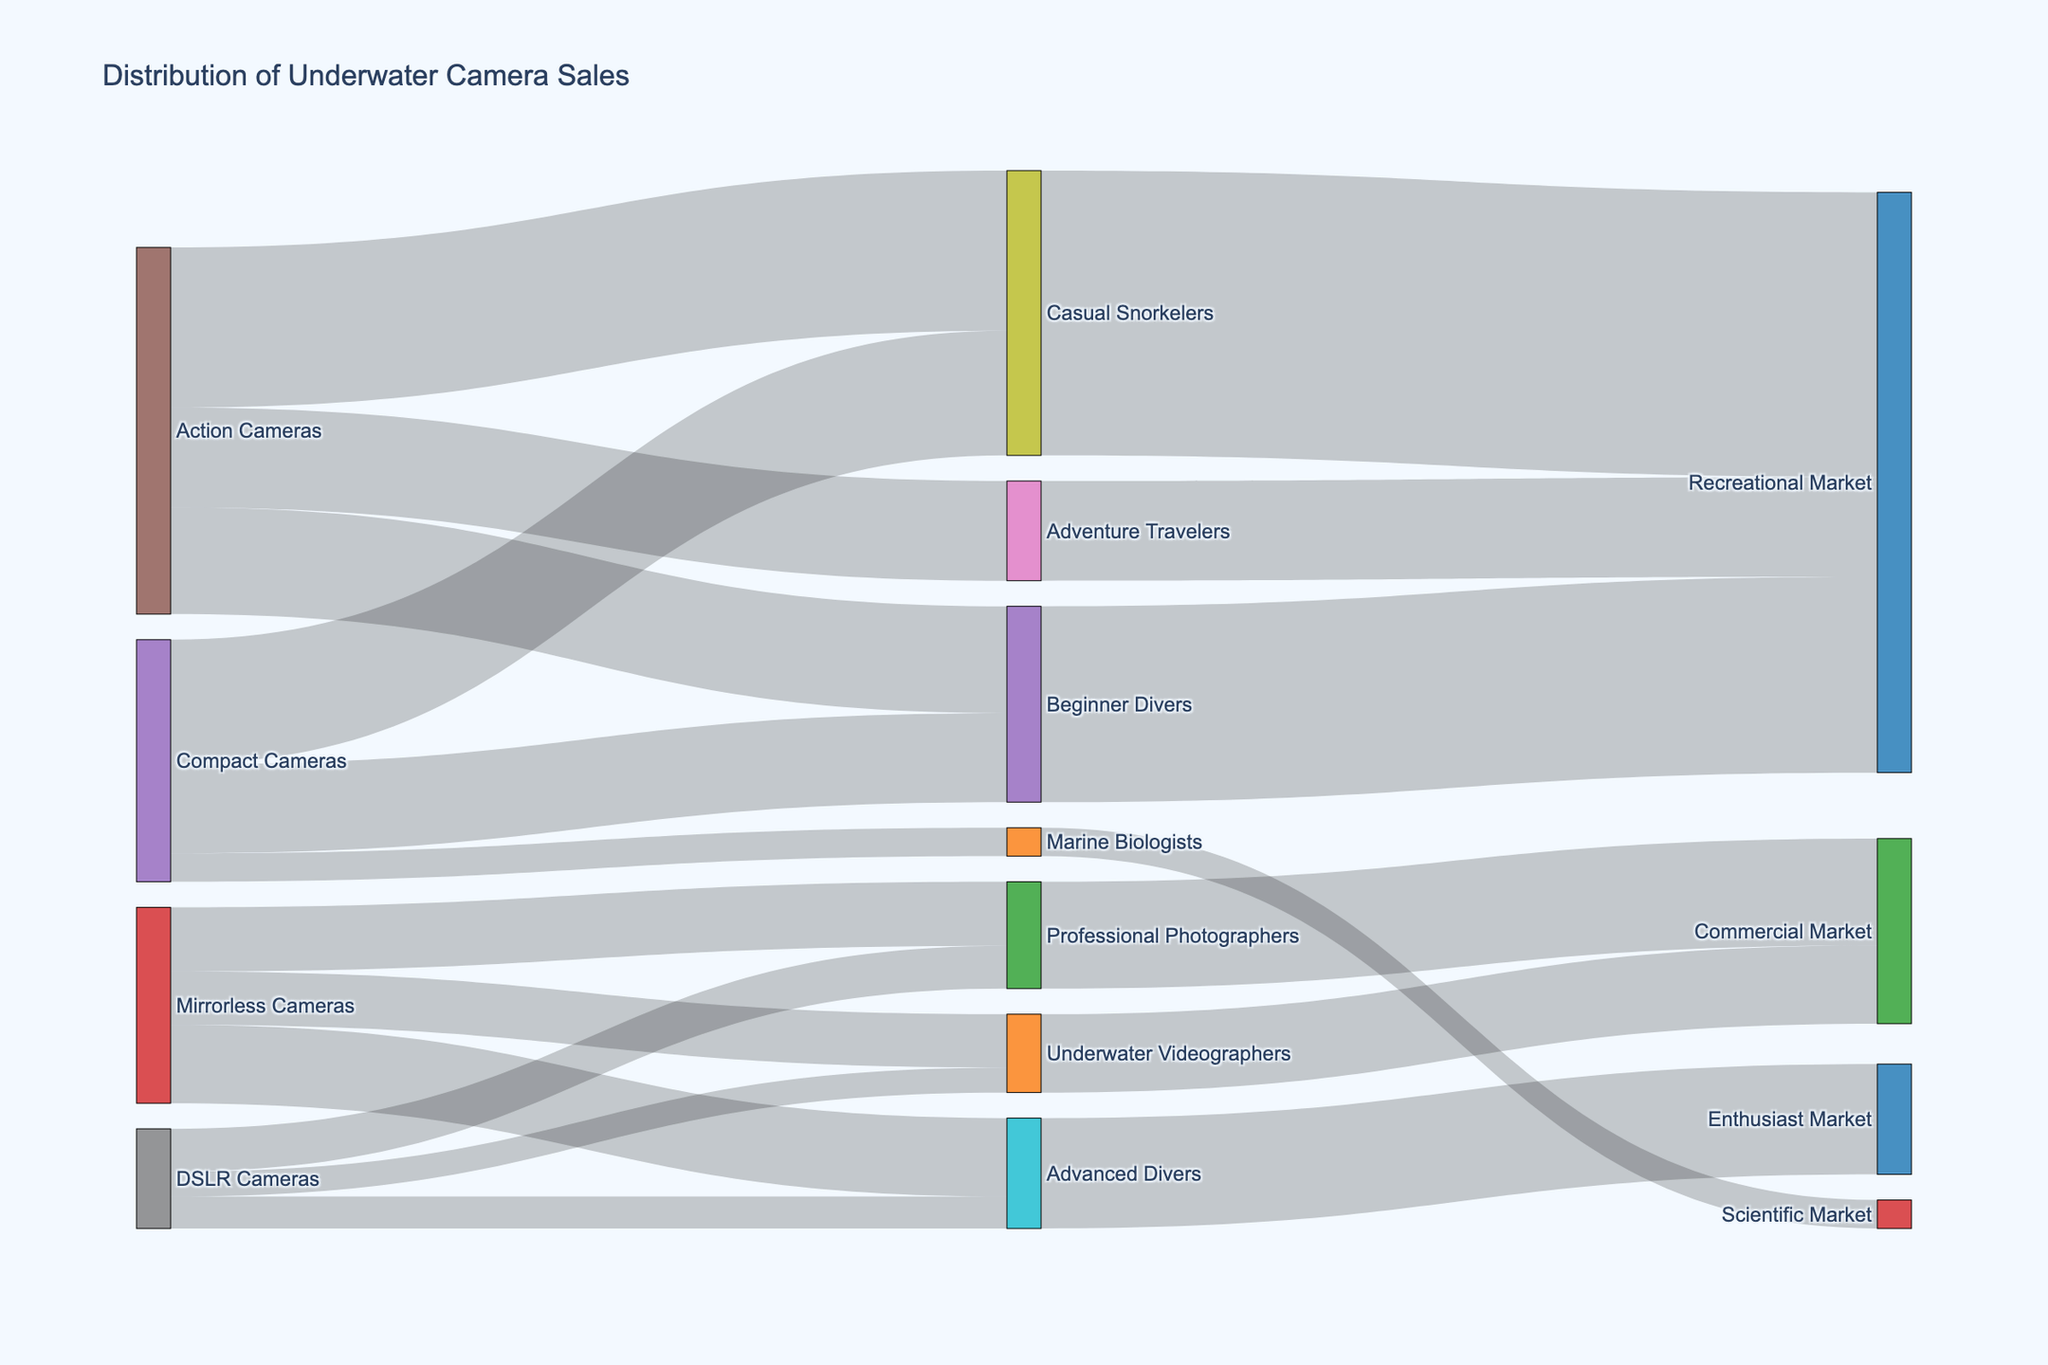What's the title of the figure? The title is usually displayed at the top of the figure. It summarizes what the figure is about.
Answer: Distribution of Underwater Camera Sales How many product types are represented in the figure? Count the number of unique nodes that represent product types (Compact Cameras, Mirrorless Cameras, DSLR Cameras, Action Cameras).
Answer: 4 Which target market segment has the highest sales of Action Cameras? From the figure, identify the outgoing links from Action Cameras to target market segments and compare their values.
Answer: Casual Snorkelers What is the total number of sales for Compact Cameras across all target market segments? Sum the sales values for Compact Cameras for each target market segment (2500 + 3500 + 800).
Answer: 6800 Which target market segment is connected to both Compact Cameras and Action Cameras but not to either Mirrorless Cameras or DSLR Cameras? Look for the target markets connected to both Compact Cameras and Action Cameras, then find out if they also link to Mirrorless Cameras or DSLR Cameras.
Answer: Beginner Divers What is the difference in sales between Mirrorless Cameras for Professional Photographers and Advanced Divers? Subtract the sales figure for Advanced Divers from the sales for Professional Photographers (1800 - 2200).
Answer: -400 Which market segment receives the highest total sales from all cameras? Sum the sales values leading to each market segment and identify the highest sum (Recreational Market: 5500 + 8000 + 2800).
Answer: Recreational Market How many different market segments are represented in the figure? Count the number of unique market segments appearing as target nodes (Recreational Market, Scientific Market, Commercial Market, Enthusiast Market).
Answer: 4 Which product type has the smallest total sales? Sum the sales values for each product type and identify the smallest sum (DSLR Cameras: 1200 + 900 + 700).
Answer: DSLR Cameras Describe the flow of sales from Compact Cameras to their final markets. First, identify the target market segments linked to Compact Cameras. Then trace each target segment to its final market, summing the sales values when the same final market is reached by different paths (Beginner Divers & Casual Snorkelers lead to Recreational Market; Marine Biologists lead to Scientific Market).
Answer: Recreational Market: 6000, Scientific Market: 800 